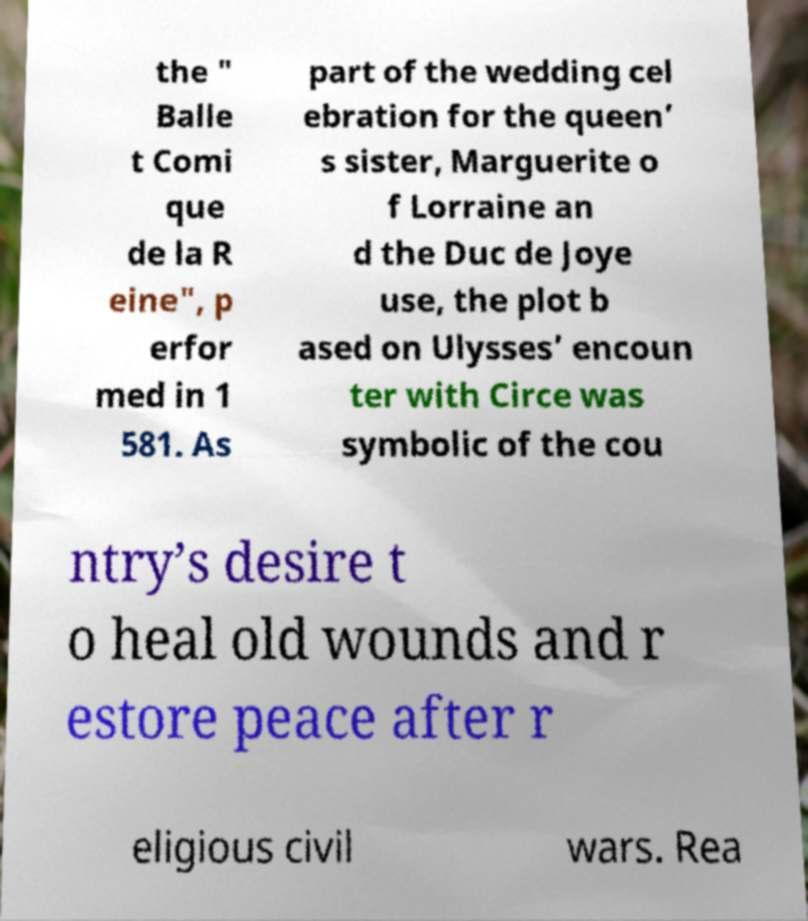Can you accurately transcribe the text from the provided image for me? the " Balle t Comi que de la R eine", p erfor med in 1 581. As part of the wedding cel ebration for the queen’ s sister, Marguerite o f Lorraine an d the Duc de Joye use, the plot b ased on Ulysses’ encoun ter with Circe was symbolic of the cou ntry’s desire t o heal old wounds and r estore peace after r eligious civil wars. Rea 